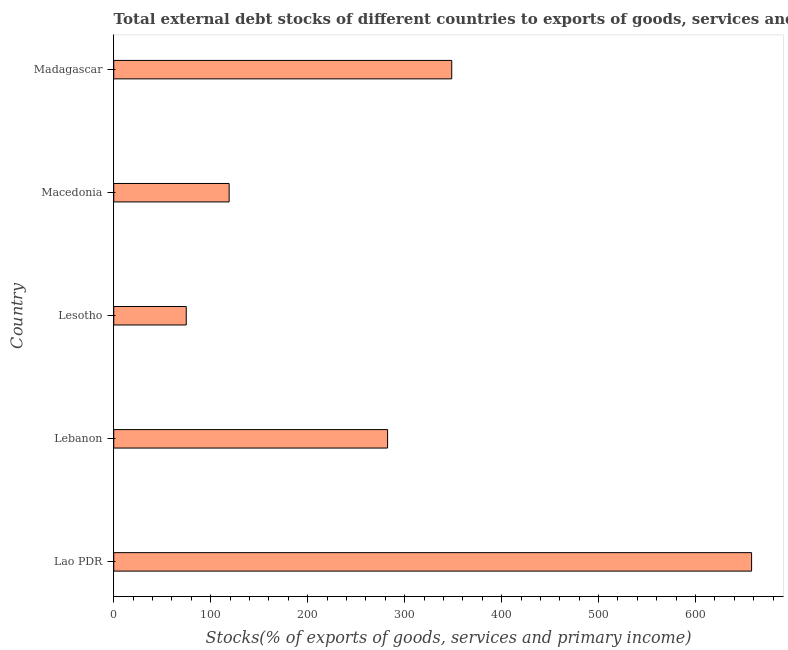Does the graph contain any zero values?
Keep it short and to the point. No. What is the title of the graph?
Provide a short and direct response. Total external debt stocks of different countries to exports of goods, services and primary income in 2002. What is the label or title of the X-axis?
Make the answer very short. Stocks(% of exports of goods, services and primary income). What is the label or title of the Y-axis?
Ensure brevity in your answer.  Country. What is the external debt stocks in Lebanon?
Your answer should be compact. 282.42. Across all countries, what is the maximum external debt stocks?
Your answer should be very brief. 657.82. Across all countries, what is the minimum external debt stocks?
Your answer should be compact. 74.78. In which country was the external debt stocks maximum?
Offer a very short reply. Lao PDR. In which country was the external debt stocks minimum?
Your answer should be compact. Lesotho. What is the sum of the external debt stocks?
Ensure brevity in your answer.  1482.61. What is the difference between the external debt stocks in Lebanon and Madagascar?
Offer a very short reply. -66.15. What is the average external debt stocks per country?
Provide a short and direct response. 296.52. What is the median external debt stocks?
Offer a terse response. 282.42. In how many countries, is the external debt stocks greater than 60 %?
Keep it short and to the point. 5. What is the ratio of the external debt stocks in Lebanon to that in Madagascar?
Your answer should be compact. 0.81. Is the external debt stocks in Lao PDR less than that in Madagascar?
Your answer should be very brief. No. Is the difference between the external debt stocks in Macedonia and Madagascar greater than the difference between any two countries?
Ensure brevity in your answer.  No. What is the difference between the highest and the second highest external debt stocks?
Make the answer very short. 309.25. What is the difference between the highest and the lowest external debt stocks?
Keep it short and to the point. 583.04. In how many countries, is the external debt stocks greater than the average external debt stocks taken over all countries?
Provide a succinct answer. 2. How many countries are there in the graph?
Give a very brief answer. 5. Are the values on the major ticks of X-axis written in scientific E-notation?
Provide a succinct answer. No. What is the Stocks(% of exports of goods, services and primary income) in Lao PDR?
Give a very brief answer. 657.82. What is the Stocks(% of exports of goods, services and primary income) in Lebanon?
Your answer should be compact. 282.42. What is the Stocks(% of exports of goods, services and primary income) in Lesotho?
Your answer should be compact. 74.78. What is the Stocks(% of exports of goods, services and primary income) of Macedonia?
Make the answer very short. 119.02. What is the Stocks(% of exports of goods, services and primary income) of Madagascar?
Provide a short and direct response. 348.57. What is the difference between the Stocks(% of exports of goods, services and primary income) in Lao PDR and Lebanon?
Your answer should be compact. 375.41. What is the difference between the Stocks(% of exports of goods, services and primary income) in Lao PDR and Lesotho?
Provide a short and direct response. 583.04. What is the difference between the Stocks(% of exports of goods, services and primary income) in Lao PDR and Macedonia?
Your answer should be compact. 538.81. What is the difference between the Stocks(% of exports of goods, services and primary income) in Lao PDR and Madagascar?
Give a very brief answer. 309.25. What is the difference between the Stocks(% of exports of goods, services and primary income) in Lebanon and Lesotho?
Offer a terse response. 207.64. What is the difference between the Stocks(% of exports of goods, services and primary income) in Lebanon and Macedonia?
Make the answer very short. 163.4. What is the difference between the Stocks(% of exports of goods, services and primary income) in Lebanon and Madagascar?
Give a very brief answer. -66.15. What is the difference between the Stocks(% of exports of goods, services and primary income) in Lesotho and Macedonia?
Provide a short and direct response. -44.24. What is the difference between the Stocks(% of exports of goods, services and primary income) in Lesotho and Madagascar?
Your response must be concise. -273.79. What is the difference between the Stocks(% of exports of goods, services and primary income) in Macedonia and Madagascar?
Your answer should be very brief. -229.55. What is the ratio of the Stocks(% of exports of goods, services and primary income) in Lao PDR to that in Lebanon?
Provide a succinct answer. 2.33. What is the ratio of the Stocks(% of exports of goods, services and primary income) in Lao PDR to that in Lesotho?
Provide a short and direct response. 8.8. What is the ratio of the Stocks(% of exports of goods, services and primary income) in Lao PDR to that in Macedonia?
Provide a short and direct response. 5.53. What is the ratio of the Stocks(% of exports of goods, services and primary income) in Lao PDR to that in Madagascar?
Give a very brief answer. 1.89. What is the ratio of the Stocks(% of exports of goods, services and primary income) in Lebanon to that in Lesotho?
Make the answer very short. 3.78. What is the ratio of the Stocks(% of exports of goods, services and primary income) in Lebanon to that in Macedonia?
Keep it short and to the point. 2.37. What is the ratio of the Stocks(% of exports of goods, services and primary income) in Lebanon to that in Madagascar?
Make the answer very short. 0.81. What is the ratio of the Stocks(% of exports of goods, services and primary income) in Lesotho to that in Macedonia?
Ensure brevity in your answer.  0.63. What is the ratio of the Stocks(% of exports of goods, services and primary income) in Lesotho to that in Madagascar?
Keep it short and to the point. 0.21. What is the ratio of the Stocks(% of exports of goods, services and primary income) in Macedonia to that in Madagascar?
Provide a short and direct response. 0.34. 